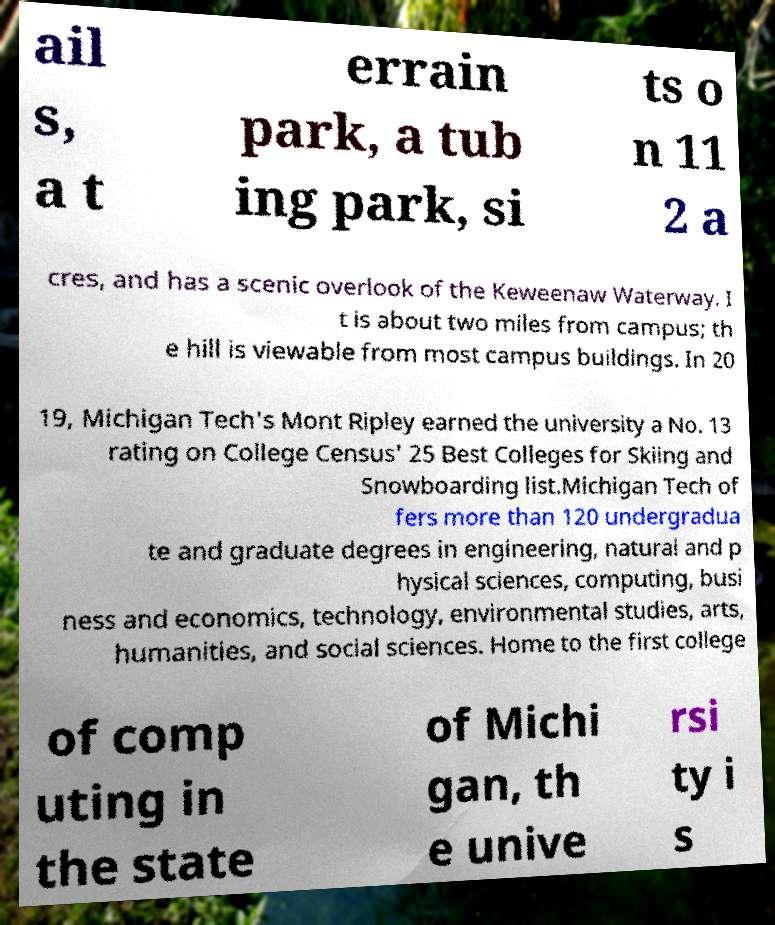Can you accurately transcribe the text from the provided image for me? ail s, a t errain park, a tub ing park, si ts o n 11 2 a cres, and has a scenic overlook of the Keweenaw Waterway. I t is about two miles from campus; th e hill is viewable from most campus buildings. In 20 19, Michigan Tech's Mont Ripley earned the university a No. 13 rating on College Census' 25 Best Colleges for Skiing and Snowboarding list.Michigan Tech of fers more than 120 undergradua te and graduate degrees in engineering, natural and p hysical sciences, computing, busi ness and economics, technology, environmental studies, arts, humanities, and social sciences. Home to the first college of comp uting in the state of Michi gan, th e unive rsi ty i s 